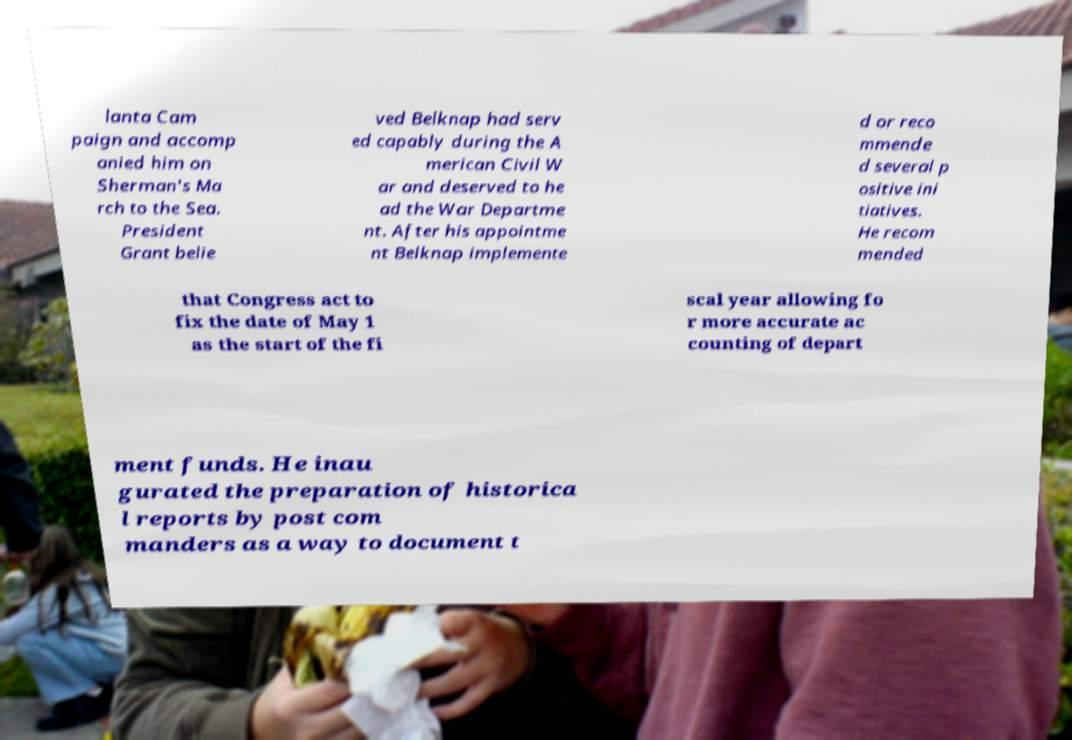Please identify and transcribe the text found in this image. lanta Cam paign and accomp anied him on Sherman's Ma rch to the Sea. President Grant belie ved Belknap had serv ed capably during the A merican Civil W ar and deserved to he ad the War Departme nt. After his appointme nt Belknap implemente d or reco mmende d several p ositive ini tiatives. He recom mended that Congress act to fix the date of May 1 as the start of the fi scal year allowing fo r more accurate ac counting of depart ment funds. He inau gurated the preparation of historica l reports by post com manders as a way to document t 